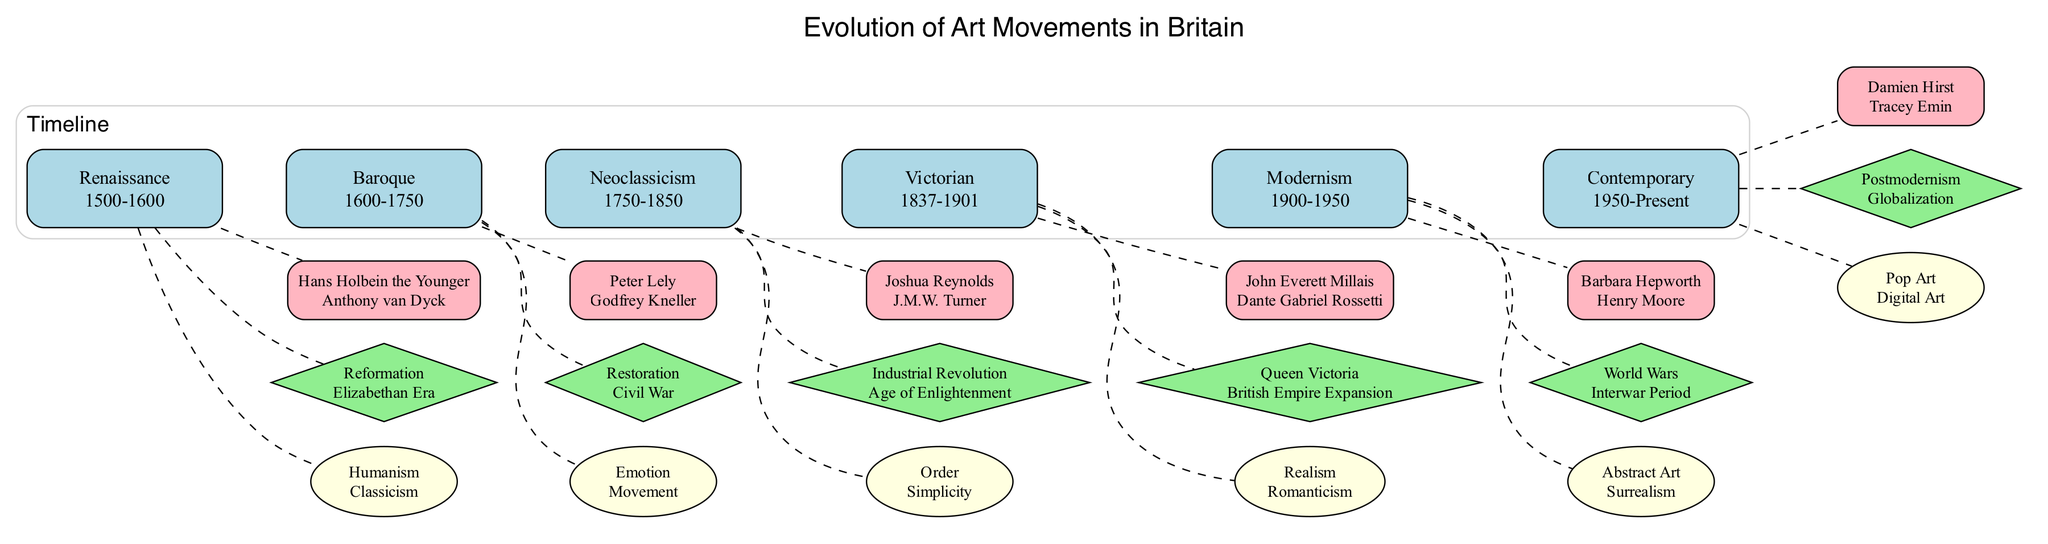What are the key styles of the Victorian period? By examining the node that represents the Victorian period, the key styles listed are "Realism" and "Romanticism."
Answer: Realism, Romanticism Which socio-political influence corresponds to the Neoclassicism period? The node for Neoclassicism lists "Industrial Revolution" and "Age of Enlightenment" as socio-political influences.
Answer: Industrial Revolution, Age of Enlightenment How many notable artists are associated with the Modernism period? The Modernism period contains a node listing "Barbara Hepworth" and "Henry Moore" as notable artists, which counts as two artists.
Answer: 2 Which movement is characterized by the key styles of "Pop Art" and "Digital Art"? The Contemporary period in the diagram clearly shows these key styles associated with it.
Answer: Contemporary Identify the period that was influenced by the Civil War. The node for Baroque mentions "Civil War" as one of its socio-political influences.
Answer: Baroque Which two art movements were active between the years of 1750 and 1950? To find these movements, we refer to the nodes from Neoclassicism (1750-1850) and Modernism (1900-1950), confirming both were active in that timeframe.
Answer: Neoclassicism, Modernism How many total art movements are listed in the diagram? Counting each period node shown in the timeline identifies a total of six distinct art movements listed.
Answer: 6 What notable artist is linked to the Victorian movement? The Victorian period's notable artists include "John Everett Millais" and "Dante Gabriel Rossetti," indicating both are linked to this movement.
Answer: John Everett Millais, Dante Gabriel Rossetti Which art movement emerged due to Postmodernism influences? The Contemporary period node specifically notes "Postmodernism" as a socio-political influence leading to the styles within that period.
Answer: Contemporary 